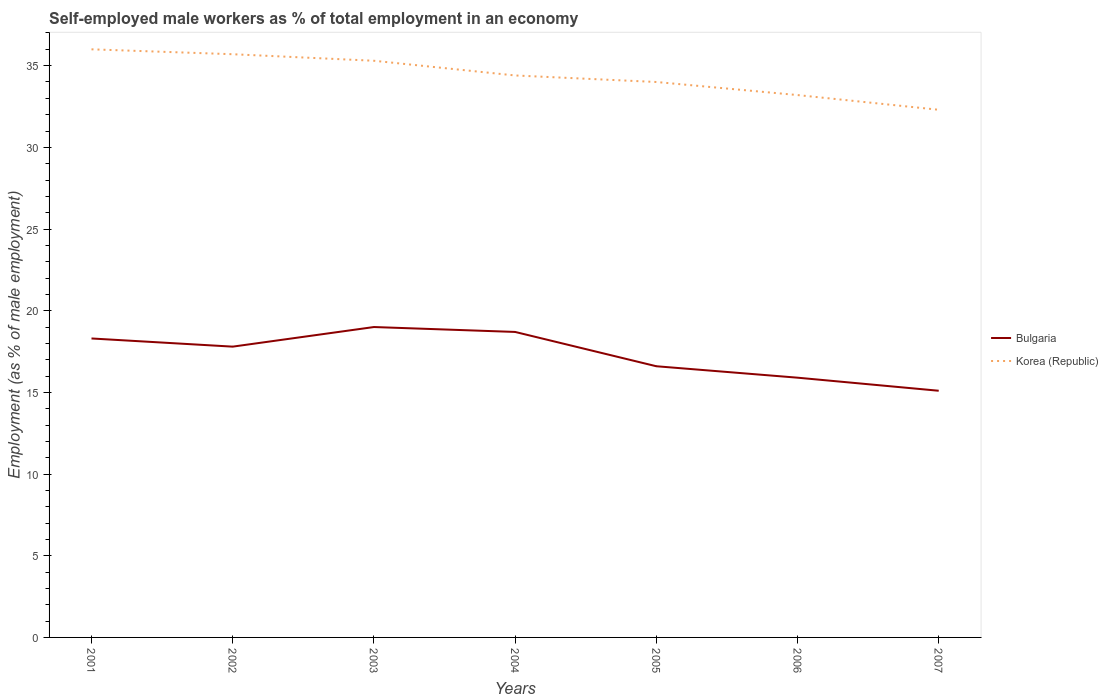Does the line corresponding to Korea (Republic) intersect with the line corresponding to Bulgaria?
Offer a very short reply. No. Across all years, what is the maximum percentage of self-employed male workers in Bulgaria?
Offer a terse response. 15.1. In which year was the percentage of self-employed male workers in Korea (Republic) maximum?
Provide a succinct answer. 2007. What is the total percentage of self-employed male workers in Korea (Republic) in the graph?
Make the answer very short. 1.3. What is the difference between the highest and the second highest percentage of self-employed male workers in Bulgaria?
Ensure brevity in your answer.  3.9. What is the difference between the highest and the lowest percentage of self-employed male workers in Bulgaria?
Provide a succinct answer. 4. Is the percentage of self-employed male workers in Korea (Republic) strictly greater than the percentage of self-employed male workers in Bulgaria over the years?
Ensure brevity in your answer.  No. How many years are there in the graph?
Your answer should be very brief. 7. Are the values on the major ticks of Y-axis written in scientific E-notation?
Ensure brevity in your answer.  No. Does the graph contain any zero values?
Ensure brevity in your answer.  No. How many legend labels are there?
Your answer should be compact. 2. What is the title of the graph?
Your answer should be very brief. Self-employed male workers as % of total employment in an economy. Does "Barbados" appear as one of the legend labels in the graph?
Provide a succinct answer. No. What is the label or title of the Y-axis?
Ensure brevity in your answer.  Employment (as % of male employment). What is the Employment (as % of male employment) of Bulgaria in 2001?
Your answer should be very brief. 18.3. What is the Employment (as % of male employment) of Korea (Republic) in 2001?
Your answer should be very brief. 36. What is the Employment (as % of male employment) in Bulgaria in 2002?
Offer a very short reply. 17.8. What is the Employment (as % of male employment) of Korea (Republic) in 2002?
Your response must be concise. 35.7. What is the Employment (as % of male employment) of Bulgaria in 2003?
Provide a short and direct response. 19. What is the Employment (as % of male employment) of Korea (Republic) in 2003?
Your answer should be compact. 35.3. What is the Employment (as % of male employment) of Bulgaria in 2004?
Offer a very short reply. 18.7. What is the Employment (as % of male employment) in Korea (Republic) in 2004?
Your answer should be very brief. 34.4. What is the Employment (as % of male employment) in Bulgaria in 2005?
Keep it short and to the point. 16.6. What is the Employment (as % of male employment) in Korea (Republic) in 2005?
Make the answer very short. 34. What is the Employment (as % of male employment) in Bulgaria in 2006?
Offer a terse response. 15.9. What is the Employment (as % of male employment) in Korea (Republic) in 2006?
Provide a succinct answer. 33.2. What is the Employment (as % of male employment) of Bulgaria in 2007?
Provide a short and direct response. 15.1. What is the Employment (as % of male employment) of Korea (Republic) in 2007?
Provide a short and direct response. 32.3. Across all years, what is the maximum Employment (as % of male employment) in Bulgaria?
Provide a short and direct response. 19. Across all years, what is the maximum Employment (as % of male employment) in Korea (Republic)?
Make the answer very short. 36. Across all years, what is the minimum Employment (as % of male employment) in Bulgaria?
Ensure brevity in your answer.  15.1. Across all years, what is the minimum Employment (as % of male employment) of Korea (Republic)?
Offer a very short reply. 32.3. What is the total Employment (as % of male employment) in Bulgaria in the graph?
Keep it short and to the point. 121.4. What is the total Employment (as % of male employment) of Korea (Republic) in the graph?
Your answer should be compact. 240.9. What is the difference between the Employment (as % of male employment) of Bulgaria in 2001 and that in 2002?
Make the answer very short. 0.5. What is the difference between the Employment (as % of male employment) in Bulgaria in 2001 and that in 2004?
Offer a very short reply. -0.4. What is the difference between the Employment (as % of male employment) in Korea (Republic) in 2001 and that in 2004?
Your response must be concise. 1.6. What is the difference between the Employment (as % of male employment) in Korea (Republic) in 2001 and that in 2006?
Your answer should be compact. 2.8. What is the difference between the Employment (as % of male employment) in Bulgaria in 2001 and that in 2007?
Make the answer very short. 3.2. What is the difference between the Employment (as % of male employment) in Korea (Republic) in 2001 and that in 2007?
Make the answer very short. 3.7. What is the difference between the Employment (as % of male employment) of Korea (Republic) in 2002 and that in 2003?
Your response must be concise. 0.4. What is the difference between the Employment (as % of male employment) of Korea (Republic) in 2002 and that in 2005?
Offer a terse response. 1.7. What is the difference between the Employment (as % of male employment) in Bulgaria in 2002 and that in 2006?
Offer a very short reply. 1.9. What is the difference between the Employment (as % of male employment) in Korea (Republic) in 2002 and that in 2006?
Keep it short and to the point. 2.5. What is the difference between the Employment (as % of male employment) of Korea (Republic) in 2002 and that in 2007?
Offer a very short reply. 3.4. What is the difference between the Employment (as % of male employment) in Korea (Republic) in 2003 and that in 2004?
Give a very brief answer. 0.9. What is the difference between the Employment (as % of male employment) in Korea (Republic) in 2003 and that in 2005?
Give a very brief answer. 1.3. What is the difference between the Employment (as % of male employment) of Bulgaria in 2003 and that in 2006?
Make the answer very short. 3.1. What is the difference between the Employment (as % of male employment) of Bulgaria in 2003 and that in 2007?
Your response must be concise. 3.9. What is the difference between the Employment (as % of male employment) of Korea (Republic) in 2004 and that in 2005?
Provide a succinct answer. 0.4. What is the difference between the Employment (as % of male employment) of Bulgaria in 2004 and that in 2007?
Offer a terse response. 3.6. What is the difference between the Employment (as % of male employment) in Korea (Republic) in 2004 and that in 2007?
Provide a short and direct response. 2.1. What is the difference between the Employment (as % of male employment) of Korea (Republic) in 2005 and that in 2007?
Your response must be concise. 1.7. What is the difference between the Employment (as % of male employment) of Bulgaria in 2006 and that in 2007?
Your answer should be compact. 0.8. What is the difference between the Employment (as % of male employment) of Bulgaria in 2001 and the Employment (as % of male employment) of Korea (Republic) in 2002?
Your answer should be very brief. -17.4. What is the difference between the Employment (as % of male employment) in Bulgaria in 2001 and the Employment (as % of male employment) in Korea (Republic) in 2003?
Your answer should be very brief. -17. What is the difference between the Employment (as % of male employment) in Bulgaria in 2001 and the Employment (as % of male employment) in Korea (Republic) in 2004?
Give a very brief answer. -16.1. What is the difference between the Employment (as % of male employment) of Bulgaria in 2001 and the Employment (as % of male employment) of Korea (Republic) in 2005?
Make the answer very short. -15.7. What is the difference between the Employment (as % of male employment) in Bulgaria in 2001 and the Employment (as % of male employment) in Korea (Republic) in 2006?
Keep it short and to the point. -14.9. What is the difference between the Employment (as % of male employment) in Bulgaria in 2002 and the Employment (as % of male employment) in Korea (Republic) in 2003?
Offer a very short reply. -17.5. What is the difference between the Employment (as % of male employment) in Bulgaria in 2002 and the Employment (as % of male employment) in Korea (Republic) in 2004?
Make the answer very short. -16.6. What is the difference between the Employment (as % of male employment) in Bulgaria in 2002 and the Employment (as % of male employment) in Korea (Republic) in 2005?
Give a very brief answer. -16.2. What is the difference between the Employment (as % of male employment) of Bulgaria in 2002 and the Employment (as % of male employment) of Korea (Republic) in 2006?
Provide a short and direct response. -15.4. What is the difference between the Employment (as % of male employment) of Bulgaria in 2002 and the Employment (as % of male employment) of Korea (Republic) in 2007?
Provide a short and direct response. -14.5. What is the difference between the Employment (as % of male employment) in Bulgaria in 2003 and the Employment (as % of male employment) in Korea (Republic) in 2004?
Your answer should be compact. -15.4. What is the difference between the Employment (as % of male employment) of Bulgaria in 2003 and the Employment (as % of male employment) of Korea (Republic) in 2006?
Your answer should be very brief. -14.2. What is the difference between the Employment (as % of male employment) in Bulgaria in 2004 and the Employment (as % of male employment) in Korea (Republic) in 2005?
Your answer should be compact. -15.3. What is the difference between the Employment (as % of male employment) of Bulgaria in 2004 and the Employment (as % of male employment) of Korea (Republic) in 2006?
Give a very brief answer. -14.5. What is the difference between the Employment (as % of male employment) in Bulgaria in 2004 and the Employment (as % of male employment) in Korea (Republic) in 2007?
Make the answer very short. -13.6. What is the difference between the Employment (as % of male employment) in Bulgaria in 2005 and the Employment (as % of male employment) in Korea (Republic) in 2006?
Ensure brevity in your answer.  -16.6. What is the difference between the Employment (as % of male employment) of Bulgaria in 2005 and the Employment (as % of male employment) of Korea (Republic) in 2007?
Your response must be concise. -15.7. What is the difference between the Employment (as % of male employment) in Bulgaria in 2006 and the Employment (as % of male employment) in Korea (Republic) in 2007?
Give a very brief answer. -16.4. What is the average Employment (as % of male employment) in Bulgaria per year?
Provide a short and direct response. 17.34. What is the average Employment (as % of male employment) in Korea (Republic) per year?
Provide a short and direct response. 34.41. In the year 2001, what is the difference between the Employment (as % of male employment) of Bulgaria and Employment (as % of male employment) of Korea (Republic)?
Give a very brief answer. -17.7. In the year 2002, what is the difference between the Employment (as % of male employment) of Bulgaria and Employment (as % of male employment) of Korea (Republic)?
Your answer should be very brief. -17.9. In the year 2003, what is the difference between the Employment (as % of male employment) in Bulgaria and Employment (as % of male employment) in Korea (Republic)?
Offer a terse response. -16.3. In the year 2004, what is the difference between the Employment (as % of male employment) in Bulgaria and Employment (as % of male employment) in Korea (Republic)?
Provide a short and direct response. -15.7. In the year 2005, what is the difference between the Employment (as % of male employment) in Bulgaria and Employment (as % of male employment) in Korea (Republic)?
Make the answer very short. -17.4. In the year 2006, what is the difference between the Employment (as % of male employment) in Bulgaria and Employment (as % of male employment) in Korea (Republic)?
Your response must be concise. -17.3. In the year 2007, what is the difference between the Employment (as % of male employment) of Bulgaria and Employment (as % of male employment) of Korea (Republic)?
Offer a terse response. -17.2. What is the ratio of the Employment (as % of male employment) in Bulgaria in 2001 to that in 2002?
Make the answer very short. 1.03. What is the ratio of the Employment (as % of male employment) in Korea (Republic) in 2001 to that in 2002?
Offer a very short reply. 1.01. What is the ratio of the Employment (as % of male employment) of Bulgaria in 2001 to that in 2003?
Your response must be concise. 0.96. What is the ratio of the Employment (as % of male employment) in Korea (Republic) in 2001 to that in 2003?
Give a very brief answer. 1.02. What is the ratio of the Employment (as % of male employment) of Bulgaria in 2001 to that in 2004?
Your answer should be compact. 0.98. What is the ratio of the Employment (as % of male employment) in Korea (Republic) in 2001 to that in 2004?
Your response must be concise. 1.05. What is the ratio of the Employment (as % of male employment) of Bulgaria in 2001 to that in 2005?
Your response must be concise. 1.1. What is the ratio of the Employment (as % of male employment) of Korea (Republic) in 2001 to that in 2005?
Ensure brevity in your answer.  1.06. What is the ratio of the Employment (as % of male employment) in Bulgaria in 2001 to that in 2006?
Offer a very short reply. 1.15. What is the ratio of the Employment (as % of male employment) in Korea (Republic) in 2001 to that in 2006?
Give a very brief answer. 1.08. What is the ratio of the Employment (as % of male employment) in Bulgaria in 2001 to that in 2007?
Your response must be concise. 1.21. What is the ratio of the Employment (as % of male employment) of Korea (Republic) in 2001 to that in 2007?
Provide a succinct answer. 1.11. What is the ratio of the Employment (as % of male employment) of Bulgaria in 2002 to that in 2003?
Ensure brevity in your answer.  0.94. What is the ratio of the Employment (as % of male employment) of Korea (Republic) in 2002 to that in 2003?
Make the answer very short. 1.01. What is the ratio of the Employment (as % of male employment) in Bulgaria in 2002 to that in 2004?
Your response must be concise. 0.95. What is the ratio of the Employment (as % of male employment) of Korea (Republic) in 2002 to that in 2004?
Make the answer very short. 1.04. What is the ratio of the Employment (as % of male employment) of Bulgaria in 2002 to that in 2005?
Offer a very short reply. 1.07. What is the ratio of the Employment (as % of male employment) in Bulgaria in 2002 to that in 2006?
Give a very brief answer. 1.12. What is the ratio of the Employment (as % of male employment) of Korea (Republic) in 2002 to that in 2006?
Provide a short and direct response. 1.08. What is the ratio of the Employment (as % of male employment) of Bulgaria in 2002 to that in 2007?
Offer a very short reply. 1.18. What is the ratio of the Employment (as % of male employment) of Korea (Republic) in 2002 to that in 2007?
Offer a terse response. 1.11. What is the ratio of the Employment (as % of male employment) in Korea (Republic) in 2003 to that in 2004?
Keep it short and to the point. 1.03. What is the ratio of the Employment (as % of male employment) in Bulgaria in 2003 to that in 2005?
Keep it short and to the point. 1.14. What is the ratio of the Employment (as % of male employment) of Korea (Republic) in 2003 to that in 2005?
Keep it short and to the point. 1.04. What is the ratio of the Employment (as % of male employment) in Bulgaria in 2003 to that in 2006?
Your answer should be compact. 1.2. What is the ratio of the Employment (as % of male employment) in Korea (Republic) in 2003 to that in 2006?
Provide a succinct answer. 1.06. What is the ratio of the Employment (as % of male employment) of Bulgaria in 2003 to that in 2007?
Offer a very short reply. 1.26. What is the ratio of the Employment (as % of male employment) in Korea (Republic) in 2003 to that in 2007?
Provide a succinct answer. 1.09. What is the ratio of the Employment (as % of male employment) in Bulgaria in 2004 to that in 2005?
Keep it short and to the point. 1.13. What is the ratio of the Employment (as % of male employment) of Korea (Republic) in 2004 to that in 2005?
Keep it short and to the point. 1.01. What is the ratio of the Employment (as % of male employment) of Bulgaria in 2004 to that in 2006?
Your answer should be very brief. 1.18. What is the ratio of the Employment (as % of male employment) in Korea (Republic) in 2004 to that in 2006?
Your response must be concise. 1.04. What is the ratio of the Employment (as % of male employment) of Bulgaria in 2004 to that in 2007?
Offer a terse response. 1.24. What is the ratio of the Employment (as % of male employment) of Korea (Republic) in 2004 to that in 2007?
Offer a very short reply. 1.06. What is the ratio of the Employment (as % of male employment) in Bulgaria in 2005 to that in 2006?
Offer a terse response. 1.04. What is the ratio of the Employment (as % of male employment) in Korea (Republic) in 2005 to that in 2006?
Give a very brief answer. 1.02. What is the ratio of the Employment (as % of male employment) of Bulgaria in 2005 to that in 2007?
Offer a terse response. 1.1. What is the ratio of the Employment (as % of male employment) of Korea (Republic) in 2005 to that in 2007?
Make the answer very short. 1.05. What is the ratio of the Employment (as % of male employment) in Bulgaria in 2006 to that in 2007?
Give a very brief answer. 1.05. What is the ratio of the Employment (as % of male employment) of Korea (Republic) in 2006 to that in 2007?
Ensure brevity in your answer.  1.03. What is the difference between the highest and the second highest Employment (as % of male employment) of Bulgaria?
Provide a short and direct response. 0.3. What is the difference between the highest and the lowest Employment (as % of male employment) of Bulgaria?
Your answer should be very brief. 3.9. What is the difference between the highest and the lowest Employment (as % of male employment) of Korea (Republic)?
Offer a terse response. 3.7. 